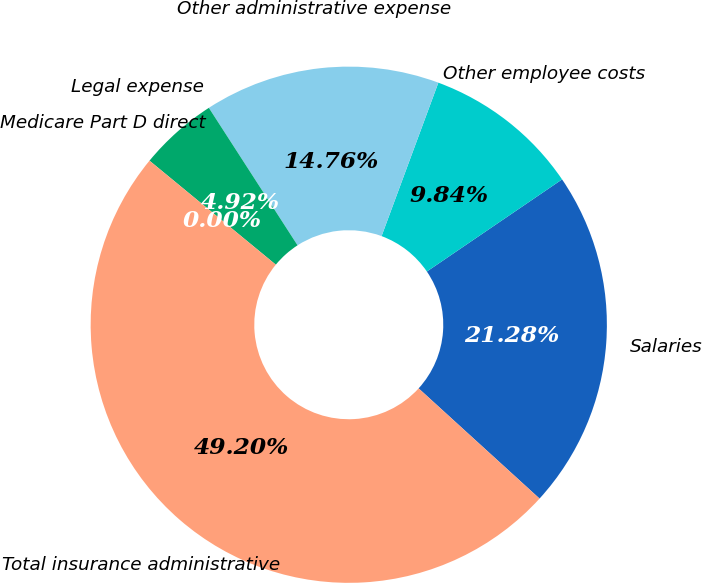<chart> <loc_0><loc_0><loc_500><loc_500><pie_chart><fcel>Salaries<fcel>Other employee costs<fcel>Other administrative expense<fcel>Legal expense<fcel>Medicare Part D direct<fcel>Total insurance administrative<nl><fcel>21.28%<fcel>9.84%<fcel>14.76%<fcel>4.92%<fcel>0.0%<fcel>49.2%<nl></chart> 